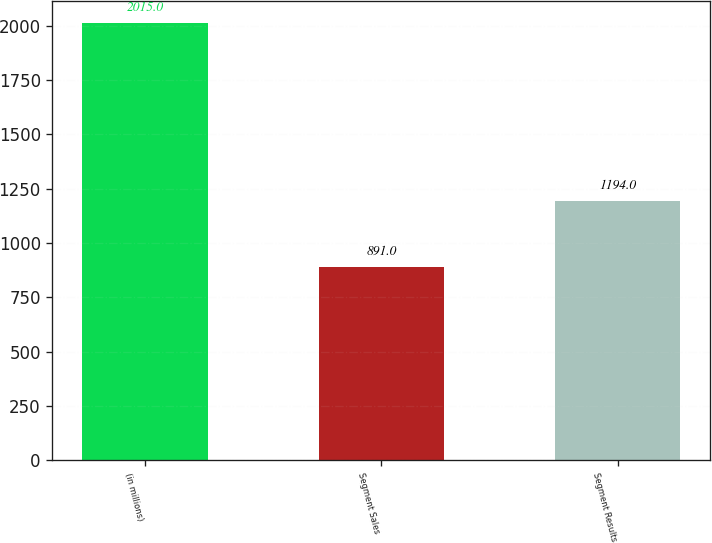Convert chart. <chart><loc_0><loc_0><loc_500><loc_500><bar_chart><fcel>(in millions)<fcel>Segment Sales<fcel>Segment Results<nl><fcel>2015<fcel>891<fcel>1194<nl></chart> 